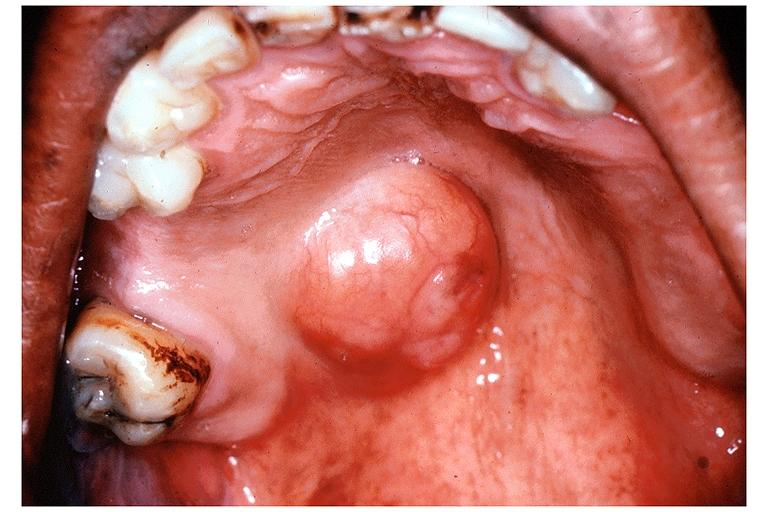where is this?
Answer the question using a single word or phrase. Oral 